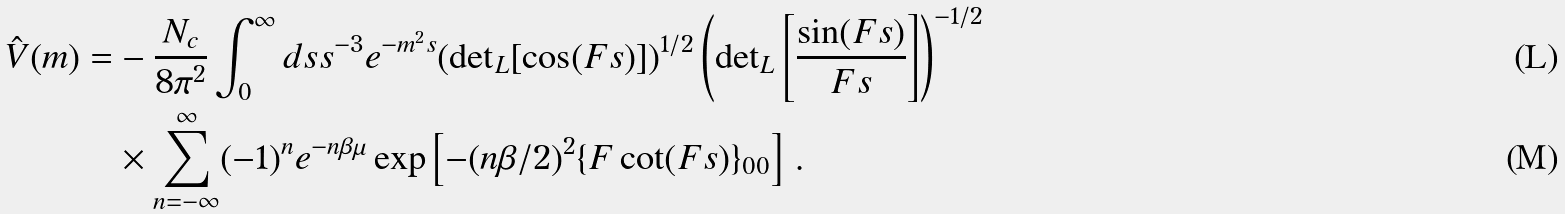Convert formula to latex. <formula><loc_0><loc_0><loc_500><loc_500>\hat { V } ( m ) = & - \frac { N _ { c } } { 8 \pi ^ { 2 } } \int _ { 0 } ^ { \infty } d s s ^ { - 3 } e ^ { - m ^ { 2 } s } ( { \det } _ { L } [ \cos ( F s ) ] ) ^ { 1 / 2 } \left ( { \det } _ { L } \left [ \frac { \sin ( F s ) } { F s } \right ] \right ) ^ { - 1 / 2 } \\ & \times \sum _ { n = - \infty } ^ { \infty } ( - 1 ) ^ { n } e ^ { - n \beta \mu } \exp \left [ - ( n \beta / 2 ) ^ { 2 } \{ F \cot ( F s ) \} _ { 0 0 } \right ] \, .</formula> 